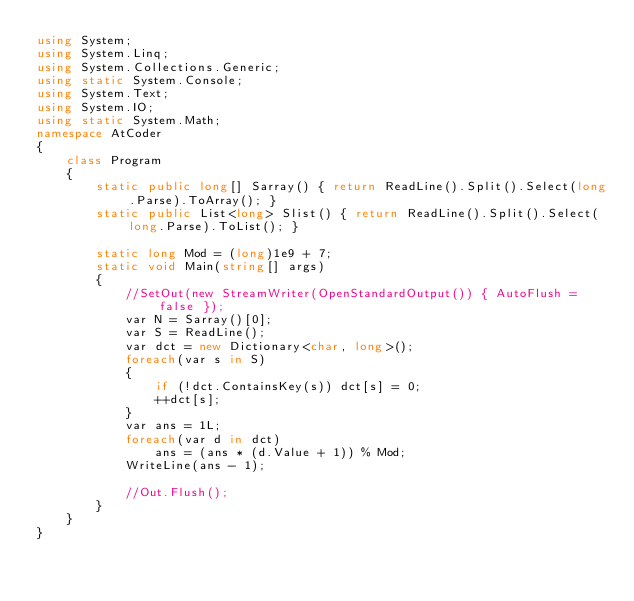<code> <loc_0><loc_0><loc_500><loc_500><_C#_>using System;
using System.Linq;
using System.Collections.Generic;
using static System.Console;
using System.Text;
using System.IO;
using static System.Math;
namespace AtCoder
{
    class Program
    {
        static public long[] Sarray() { return ReadLine().Split().Select(long.Parse).ToArray(); }
        static public List<long> Slist() { return ReadLine().Split().Select(long.Parse).ToList(); }

        static long Mod = (long)1e9 + 7;
        static void Main(string[] args)
        {
            //SetOut(new StreamWriter(OpenStandardOutput()) { AutoFlush = false });
            var N = Sarray()[0];
            var S = ReadLine();
            var dct = new Dictionary<char, long>();
            foreach(var s in S)
            {
                if (!dct.ContainsKey(s)) dct[s] = 0;
                ++dct[s];
            }
            var ans = 1L;
            foreach(var d in dct)
                ans = (ans * (d.Value + 1)) % Mod;
            WriteLine(ans - 1);

            //Out.Flush();
        }
    }
}</code> 